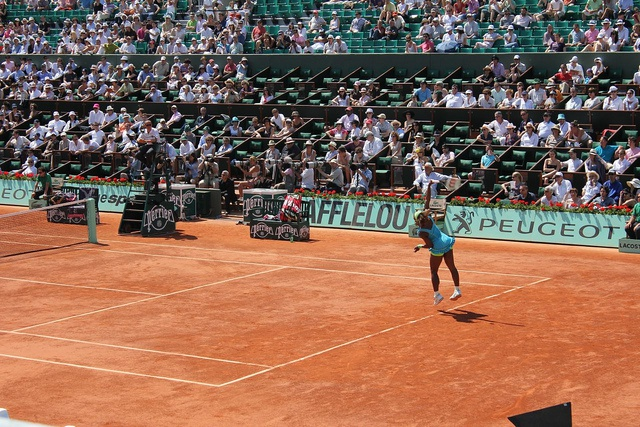Describe the objects in this image and their specific colors. I can see people in darkgray, black, maroon, blue, and teal tones, people in darkgray, black, gray, and lightgray tones, people in darkgray, lightgray, and gray tones, people in darkgray, black, and gray tones, and people in darkgray, black, gray, maroon, and brown tones in this image. 